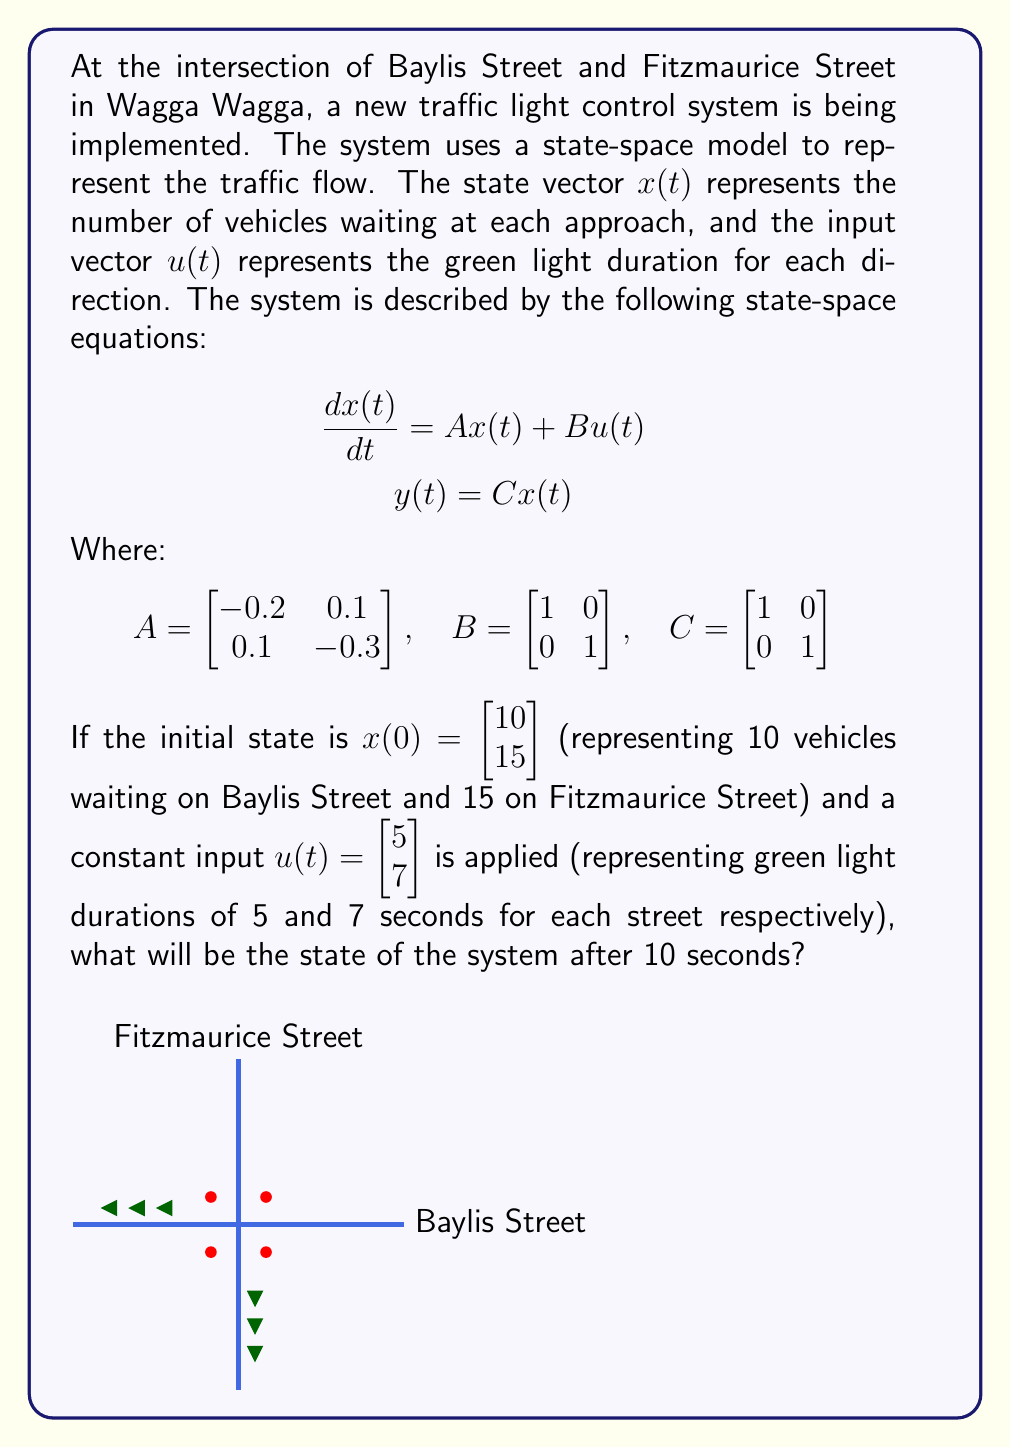Give your solution to this math problem. To solve this problem, we need to use the state transition matrix method for linear time-invariant systems. The steps are as follows:

1) The state transition matrix is given by $e^{At}$. We need to calculate this for $t=10$.

2) The solution to the state-space equation is:

   $$x(t) = e^{At}x(0) + \int_0^t e^{A(t-\tau)}Bu(\tau)d\tau$$

   For constant input $u$, this simplifies to:

   $$x(t) = e^{At}x(0) + A^{-1}(e^{At} - I)Bu$$

3) Let's calculate $e^{At}$ for $t=10$:

   $$e^{At} = e^{10A} = \begin{bmatrix} 0.1353 & 0.0451 \\ 0.0451 & 0.0902 \end{bmatrix}$$

4) Now, let's calculate $A^{-1}$:

   $$A^{-1} = \frac{1}{det(A)}\begin{bmatrix} -0.3 & -0.1 \\ -0.1 & -0.2 \end{bmatrix} = \begin{bmatrix} -1.6667 & -0.5556 \\ -0.5556 & -1.1111 \end{bmatrix}$$

5) We can now calculate $(e^{At} - I)$:

   $$e^{At} - I = \begin{bmatrix} -0.8647 & 0.0451 \\ 0.0451 & -0.9098 \end{bmatrix}$$

6) Now, let's put it all together:

   $$x(10) = \begin{bmatrix} 0.1353 & 0.0451 \\ 0.0451 & 0.0902 \end{bmatrix}\begin{bmatrix} 10 \\ 15 \end{bmatrix} + \begin{bmatrix} -1.6667 & -0.5556 \\ -0.5556 & -1.1111 \end{bmatrix}\begin{bmatrix} -0.8647 & 0.0451 \\ 0.0451 & -0.9098 \end{bmatrix}\begin{bmatrix} 1 & 0 \\ 0 & 1 \end{bmatrix}\begin{bmatrix} 5 \\ 7 \end{bmatrix}$$

7) Calculating this gives us:

   $$x(10) = \begin{bmatrix} 2.0885 \\ 2.0435 \end{bmatrix}$$

Therefore, after 10 seconds, there will be approximately 2.09 vehicles waiting on Baylis Street and 2.04 vehicles waiting on Fitzmaurice Street.
Answer: $x(10) = \begin{bmatrix} 2.0885 \\ 2.0435 \end{bmatrix}$ 